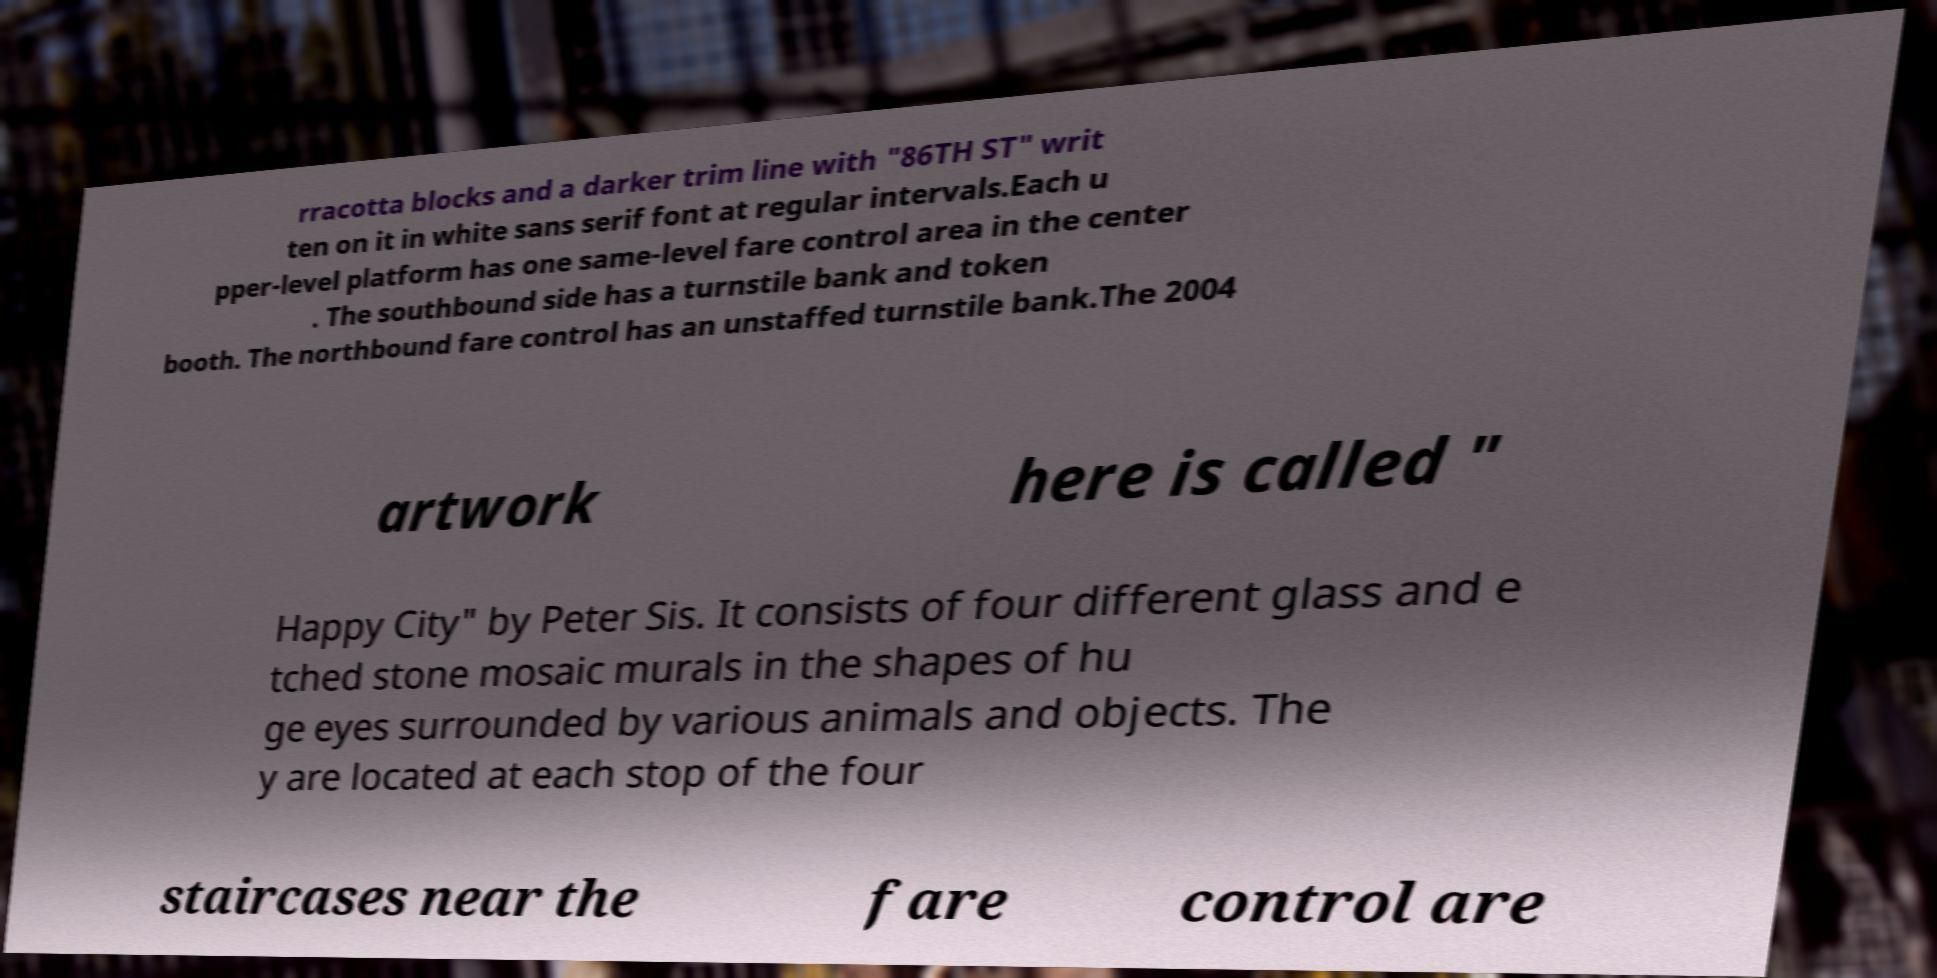What messages or text are displayed in this image? I need them in a readable, typed format. rracotta blocks and a darker trim line with "86TH ST" writ ten on it in white sans serif font at regular intervals.Each u pper-level platform has one same-level fare control area in the center . The southbound side has a turnstile bank and token booth. The northbound fare control has an unstaffed turnstile bank.The 2004 artwork here is called " Happy City" by Peter Sis. It consists of four different glass and e tched stone mosaic murals in the shapes of hu ge eyes surrounded by various animals and objects. The y are located at each stop of the four staircases near the fare control are 